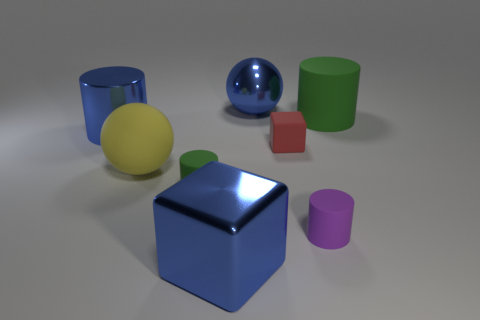What number of things are either green objects on the left side of the purple object or shiny objects behind the yellow ball?
Your answer should be very brief. 3. There is a cylinder that is to the right of the purple cylinder; does it have the same size as the large blue block?
Your answer should be very brief. Yes. There is a ball that is on the right side of the metallic cube; what color is it?
Give a very brief answer. Blue. There is another big object that is the same shape as the big green object; what color is it?
Keep it short and to the point. Blue. There is a rubber object behind the big thing to the left of the big yellow rubber sphere; what number of matte cylinders are on the left side of it?
Your answer should be compact. 2. Is the number of shiny things that are left of the large blue sphere less than the number of large blue rubber balls?
Your response must be concise. No. Does the big cube have the same color as the large metal cylinder?
Your answer should be compact. Yes. What size is the purple object that is the same shape as the tiny green thing?
Your response must be concise. Small. How many green cylinders have the same material as the small block?
Your answer should be very brief. 2. Are the large cylinder on the left side of the large metal sphere and the big blue sphere made of the same material?
Provide a succinct answer. Yes. 